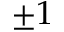<formula> <loc_0><loc_0><loc_500><loc_500>\pm 1</formula> 